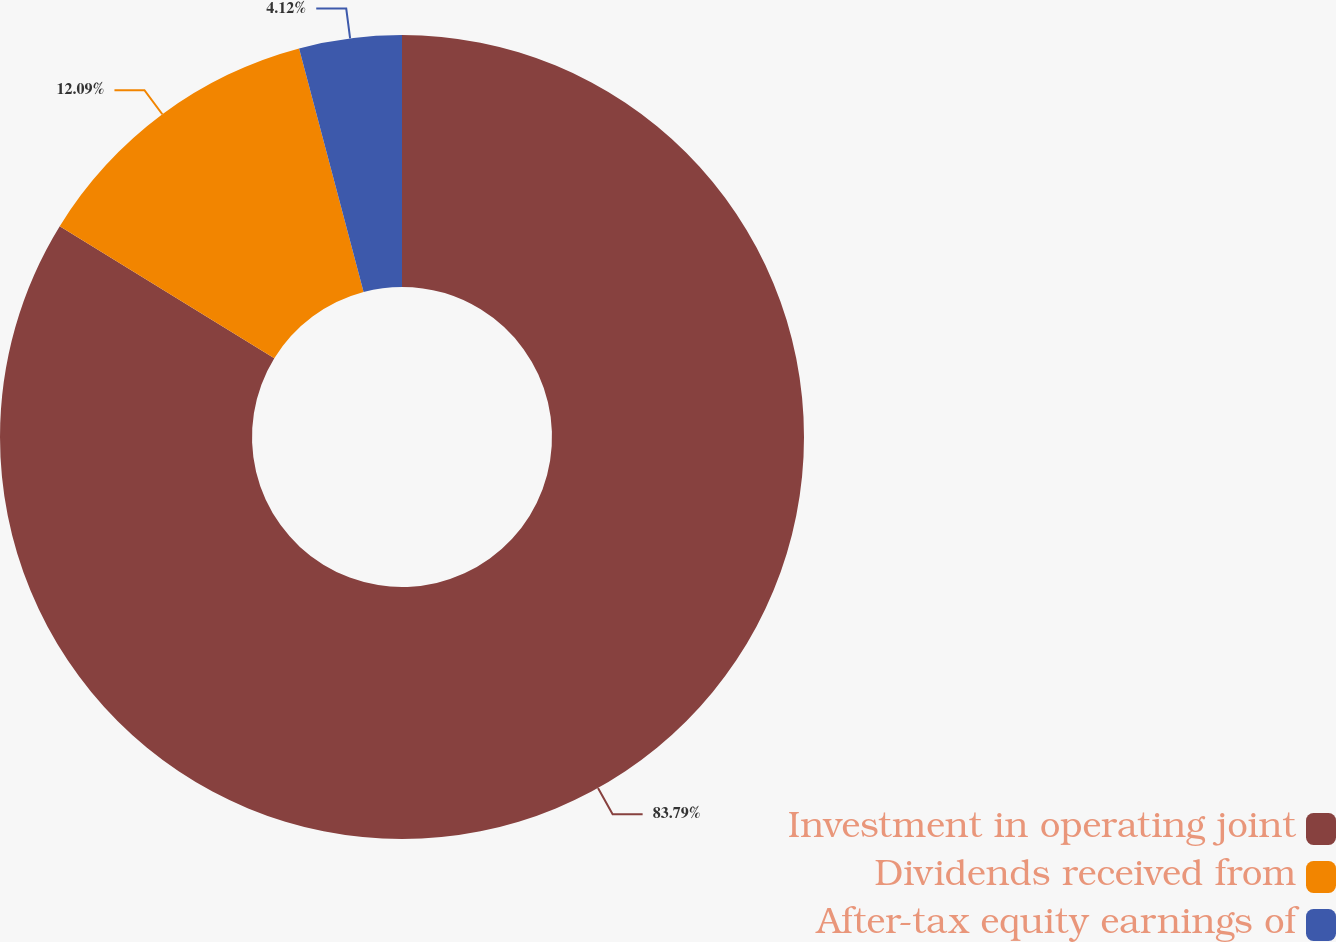Convert chart to OTSL. <chart><loc_0><loc_0><loc_500><loc_500><pie_chart><fcel>Investment in operating joint<fcel>Dividends received from<fcel>After-tax equity earnings of<nl><fcel>83.78%<fcel>12.09%<fcel>4.12%<nl></chart> 